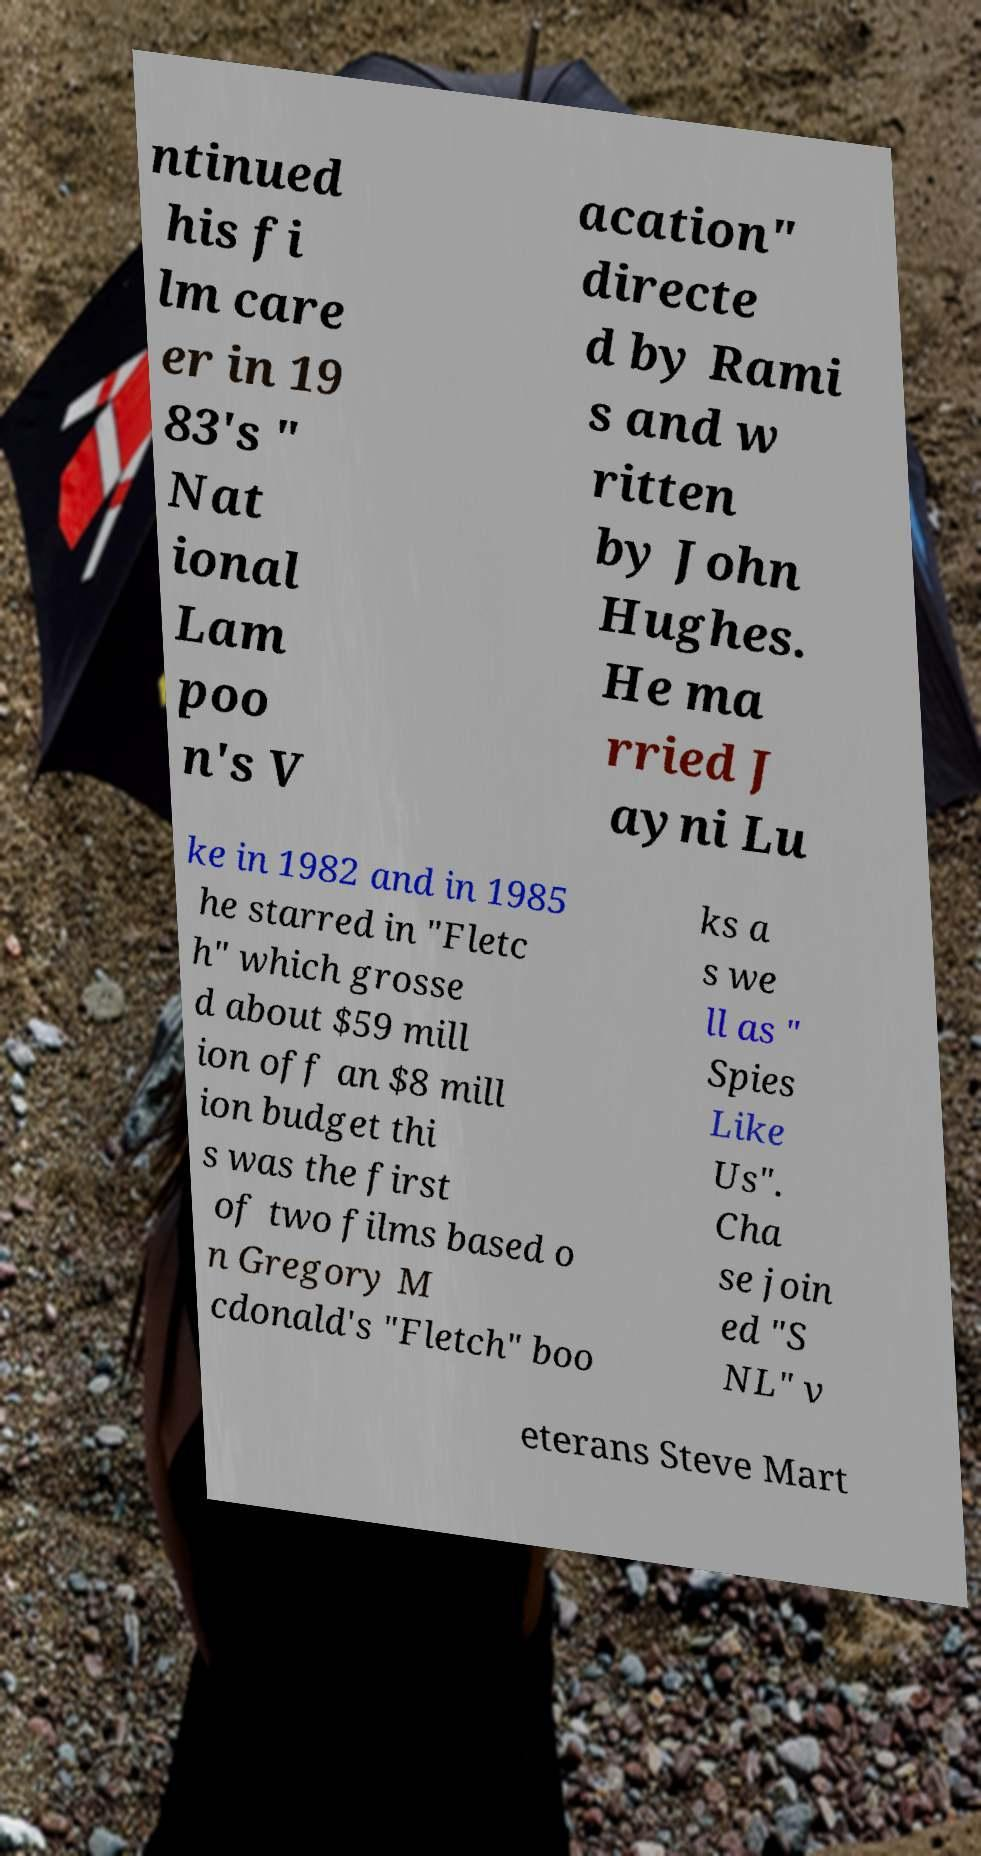What messages or text are displayed in this image? I need them in a readable, typed format. ntinued his fi lm care er in 19 83's " Nat ional Lam poo n's V acation" directe d by Rami s and w ritten by John Hughes. He ma rried J ayni Lu ke in 1982 and in 1985 he starred in "Fletc h" which grosse d about $59 mill ion off an $8 mill ion budget thi s was the first of two films based o n Gregory M cdonald's "Fletch" boo ks a s we ll as " Spies Like Us". Cha se join ed "S NL" v eterans Steve Mart 